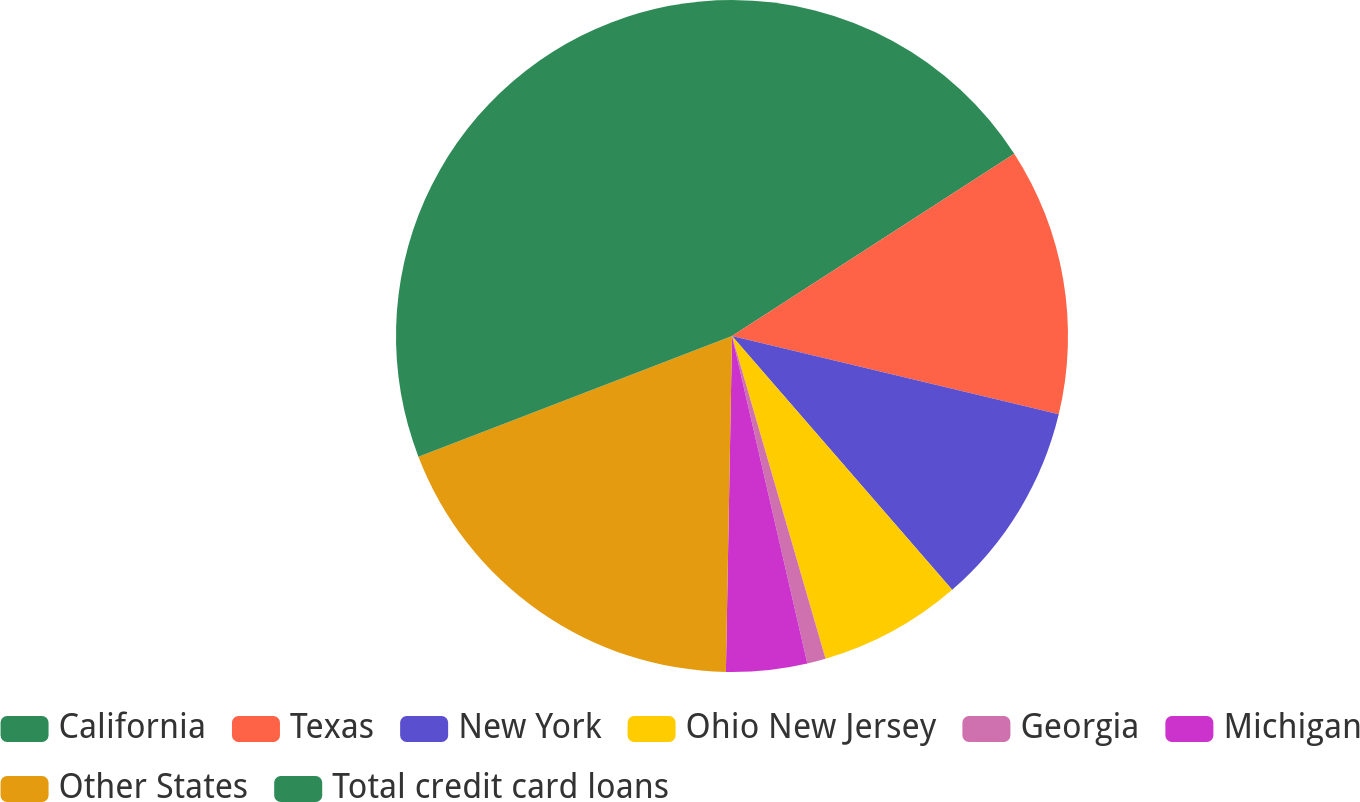Convert chart to OTSL. <chart><loc_0><loc_0><loc_500><loc_500><pie_chart><fcel>California<fcel>Texas<fcel>New York<fcel>Ohio New Jersey<fcel>Georgia<fcel>Michigan<fcel>Other States<fcel>Total credit card loans<nl><fcel>15.87%<fcel>12.87%<fcel>9.88%<fcel>6.88%<fcel>0.89%<fcel>3.89%<fcel>18.86%<fcel>30.84%<nl></chart> 